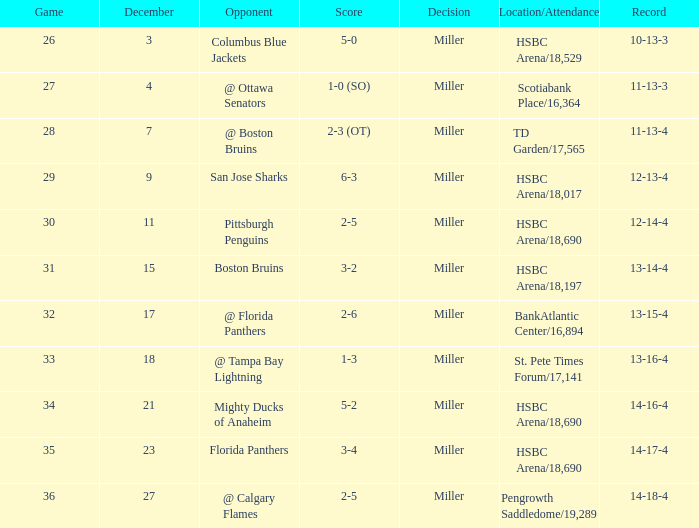Name the number of game 2-6 1.0. Would you be able to parse every entry in this table? {'header': ['Game', 'December', 'Opponent', 'Score', 'Decision', 'Location/Attendance', 'Record'], 'rows': [['26', '3', 'Columbus Blue Jackets', '5-0', 'Miller', 'HSBC Arena/18,529', '10-13-3'], ['27', '4', '@ Ottawa Senators', '1-0 (SO)', 'Miller', 'Scotiabank Place/16,364', '11-13-3'], ['28', '7', '@ Boston Bruins', '2-3 (OT)', 'Miller', 'TD Garden/17,565', '11-13-4'], ['29', '9', 'San Jose Sharks', '6-3', 'Miller', 'HSBC Arena/18,017', '12-13-4'], ['30', '11', 'Pittsburgh Penguins', '2-5', 'Miller', 'HSBC Arena/18,690', '12-14-4'], ['31', '15', 'Boston Bruins', '3-2', 'Miller', 'HSBC Arena/18,197', '13-14-4'], ['32', '17', '@ Florida Panthers', '2-6', 'Miller', 'BankAtlantic Center/16,894', '13-15-4'], ['33', '18', '@ Tampa Bay Lightning', '1-3', 'Miller', 'St. Pete Times Forum/17,141', '13-16-4'], ['34', '21', 'Mighty Ducks of Anaheim', '5-2', 'Miller', 'HSBC Arena/18,690', '14-16-4'], ['35', '23', 'Florida Panthers', '3-4', 'Miller', 'HSBC Arena/18,690', '14-17-4'], ['36', '27', '@ Calgary Flames', '2-5', 'Miller', 'Pengrowth Saddledome/19,289', '14-18-4']]} 